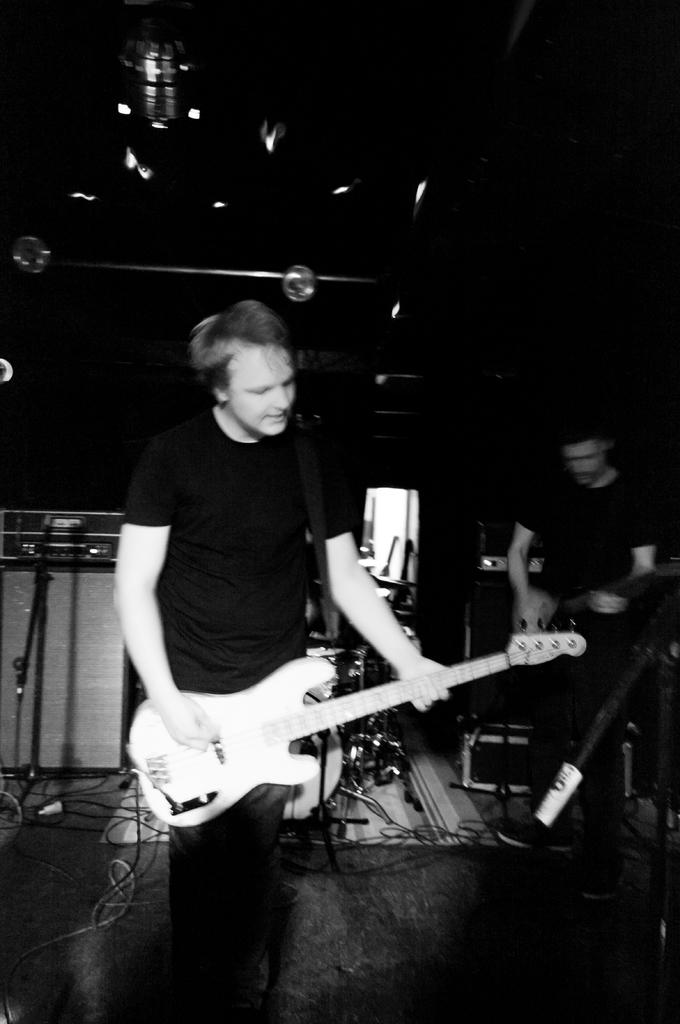What is the man in the foreground of the image doing? The man is standing and playing a guitar. Can you describe the second man in the image? The second man is also standing and playing a guitar. What is the relationship between the two men in the image? It is not clear from the image what the relationship between the two men is, but they are both playing guitars. What type of lip balm is the man using in the image? There is no lip balm present in the image; the man is playing a guitar. 